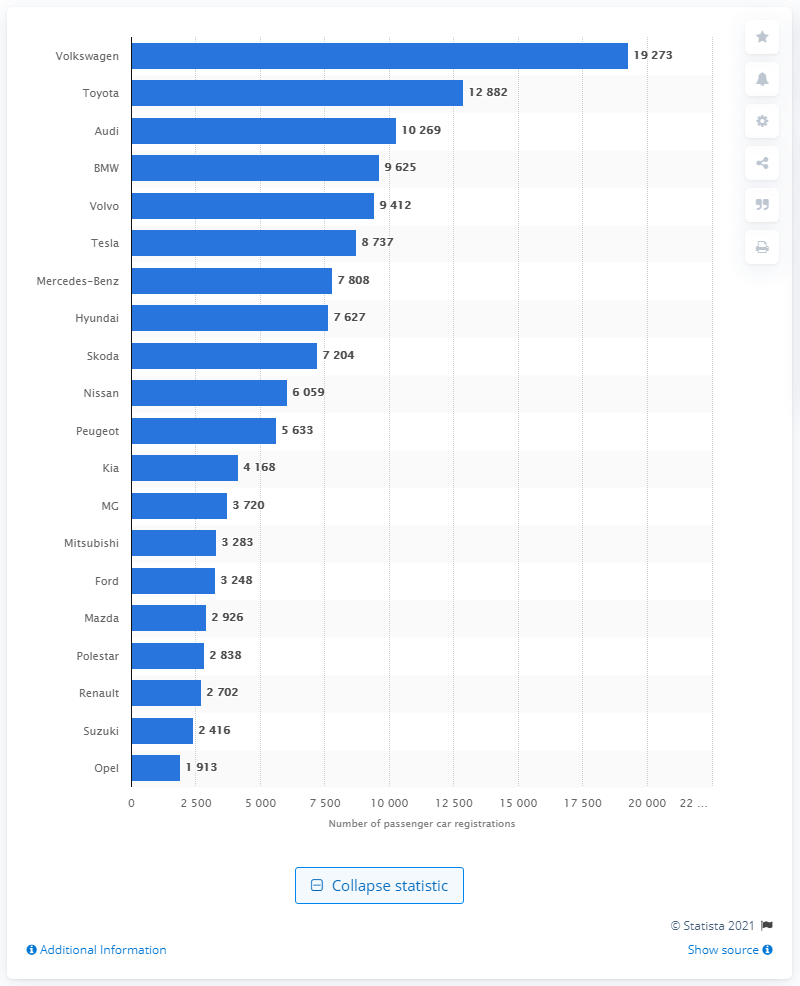Draw attention to some important aspects in this diagram. According to the sales figures, Audi was the third-best-selling car brand in Norway. In 2020, Volkswagen was the best-selling car brand in Norway. 